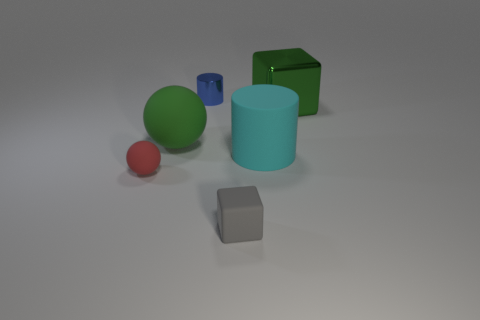Add 2 green blocks. How many objects exist? 8 Subtract all cylinders. How many objects are left? 4 Subtract all gray matte objects. Subtract all small blue cylinders. How many objects are left? 4 Add 5 metal cubes. How many metal cubes are left? 6 Add 5 small blue shiny things. How many small blue shiny things exist? 6 Subtract 0 cyan balls. How many objects are left? 6 